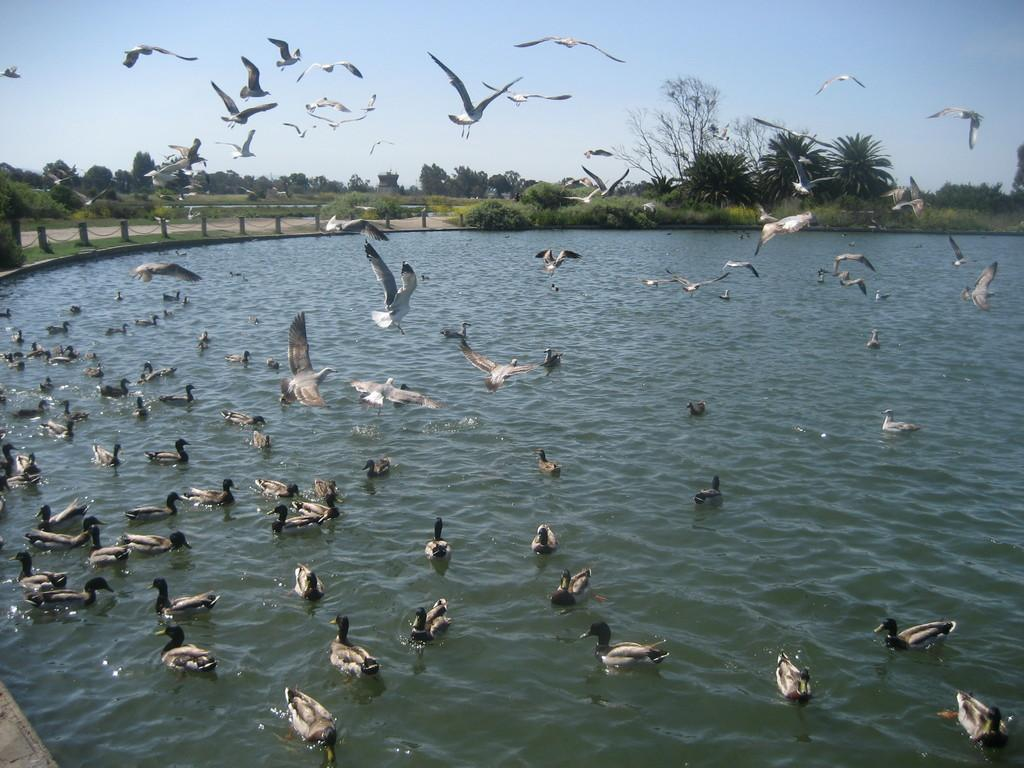What is the main element in the image? There is water in the image. What is present on the water? There are birds on the water. What are the birds doing in the image? Some birds are on the water, while others are flying in the air. What type of vegetation can be seen in the image? There are green trees in the image. What is visible in the background of the image? The sky is visible in the background of the image. What type of breakfast is being served on the water in the image? There is no breakfast present in the image; it features water, birds, trees, and the sky. 